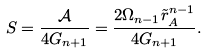<formula> <loc_0><loc_0><loc_500><loc_500>S = \frac { \mathcal { A } } { 4 G _ { n + 1 } } = \frac { 2 \Omega _ { n - 1 } \tilde { r } _ { A } ^ { n - 1 } } { 4 G _ { n + 1 } } .</formula> 